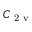Convert formula to latex. <formula><loc_0><loc_0><loc_500><loc_500>C _ { 2 v }</formula> 